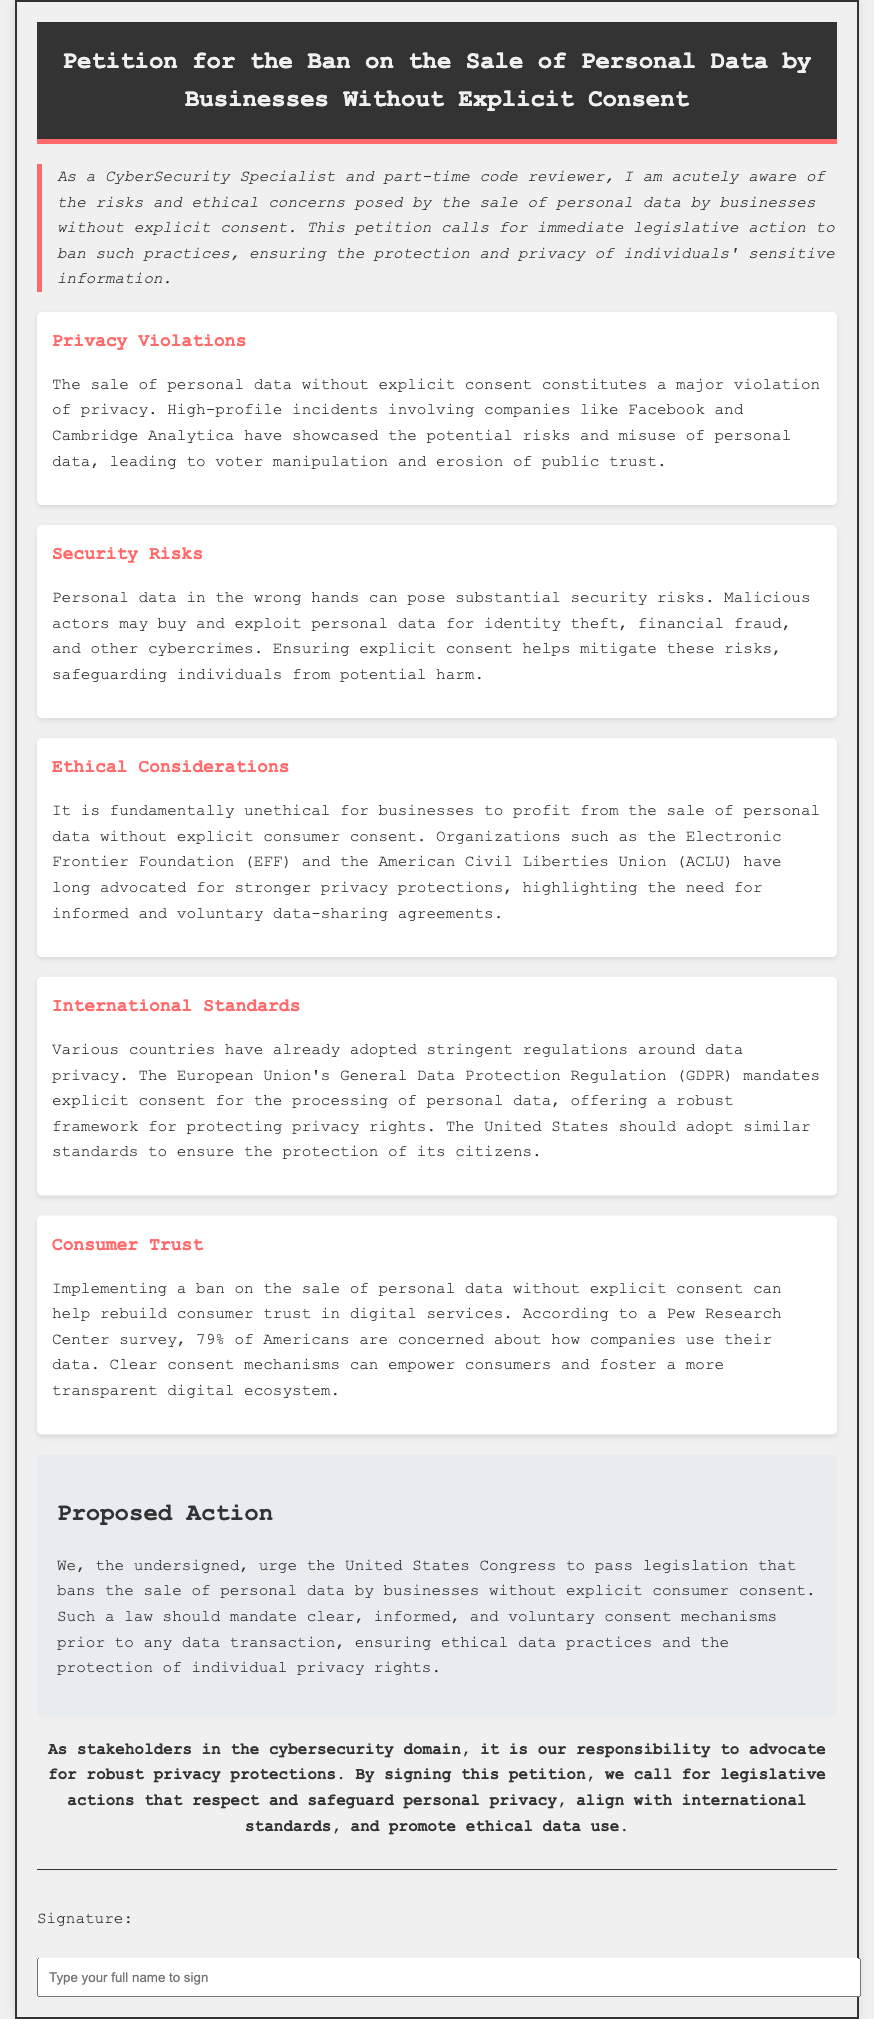What is the title of the petition? The title of the petition is located in the header section of the document.
Answer: Petition for the Ban on the Sale of Personal Data by Businesses Without Explicit Consent What organization advocates for stronger privacy protections? The document mentions organizations that have a history of advocating for privacy rights.
Answer: Electronic Frontier Foundation (EFF) What is one major consequence of personal data in the wrong hands? The document discusses the negative outcomes that can arise from personal data exploitation.
Answer: Identity theft What percentage of Americans are concerned about how companies use their data? This information is derived from a survey mentioned in the consumer trust section of the document.
Answer: 79% What does the proposed legislation aim to ban? The specific aim of the proposed legislation is highlighted in the proposed action section.
Answer: Sale of personal data without explicit consumer consent What ethical issue is raised regarding the sale of personal data? The document emphasizes a fundamental concern regarding ethics in data sales.
Answer: Unethical profit-making Which international regulation does the document reference for privacy standards? The document references a well-known regulation that serves as a benchmark for data privacy.
Answer: General Data Protection Regulation (GDPR) What is the conclusion urging stakeholders in the cybersecurity domain to do? The conclusion outlines the expected action from stakeholders in the cybersecurity field.
Answer: Advocate for robust privacy protections 